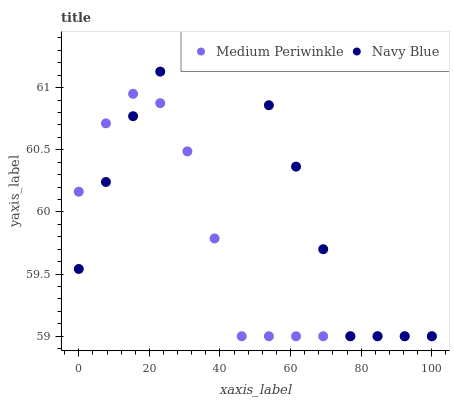Does Medium Periwinkle have the minimum area under the curve?
Answer yes or no. Yes. Does Navy Blue have the maximum area under the curve?
Answer yes or no. Yes. Does Medium Periwinkle have the maximum area under the curve?
Answer yes or no. No. Is Navy Blue the smoothest?
Answer yes or no. Yes. Is Medium Periwinkle the roughest?
Answer yes or no. Yes. Is Medium Periwinkle the smoothest?
Answer yes or no. No. Does Navy Blue have the lowest value?
Answer yes or no. Yes. Does Navy Blue have the highest value?
Answer yes or no. Yes. Does Medium Periwinkle have the highest value?
Answer yes or no. No. Does Navy Blue intersect Medium Periwinkle?
Answer yes or no. Yes. Is Navy Blue less than Medium Periwinkle?
Answer yes or no. No. Is Navy Blue greater than Medium Periwinkle?
Answer yes or no. No. 